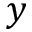Convert formula to latex. <formula><loc_0><loc_0><loc_500><loc_500>y</formula> 